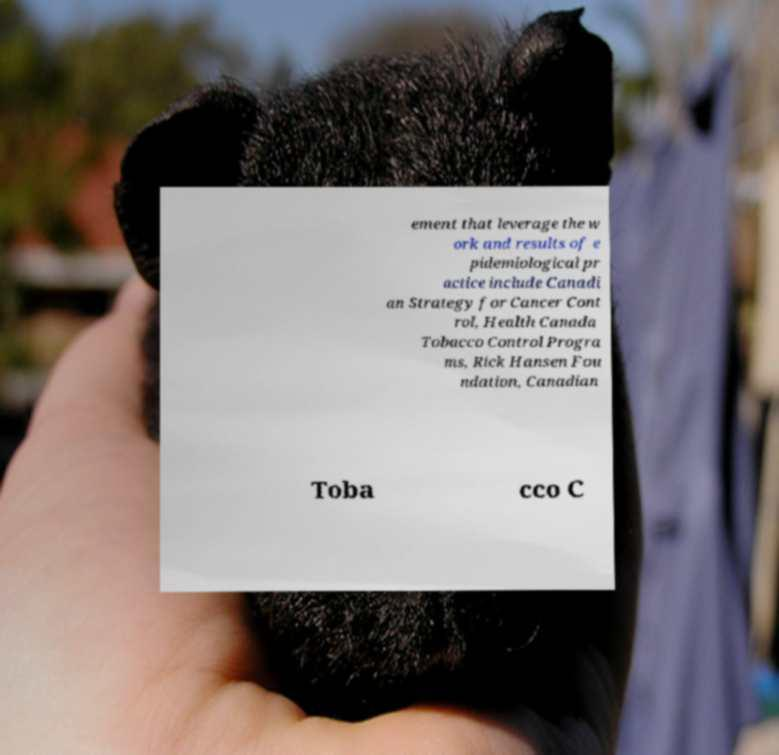For documentation purposes, I need the text within this image transcribed. Could you provide that? ement that leverage the w ork and results of e pidemiological pr actice include Canadi an Strategy for Cancer Cont rol, Health Canada Tobacco Control Progra ms, Rick Hansen Fou ndation, Canadian Toba cco C 